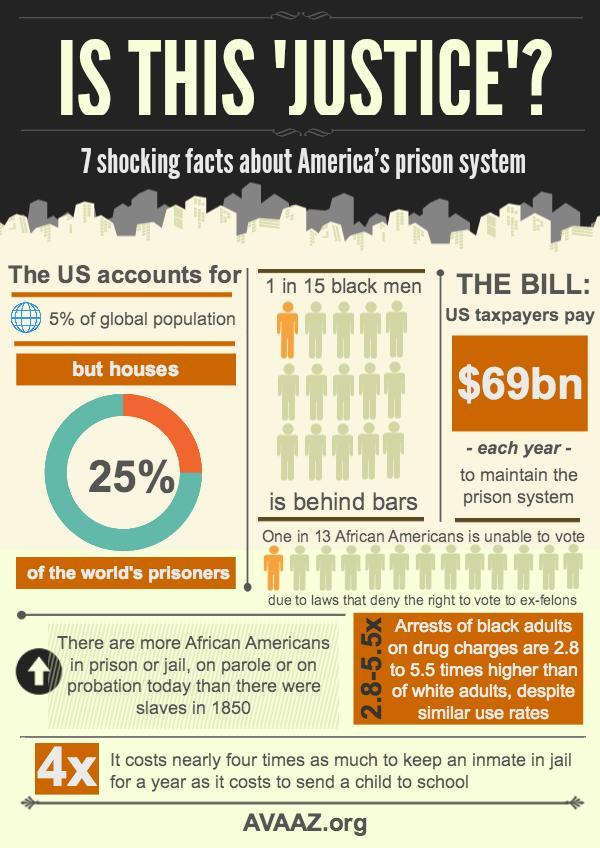Out of 15, how many black men are not behind bars?
Answer the question with a short phrase. 14 What percentage of the world's prisoners are not Americans? 75% What percentage of the global population are not Americans? 95% 